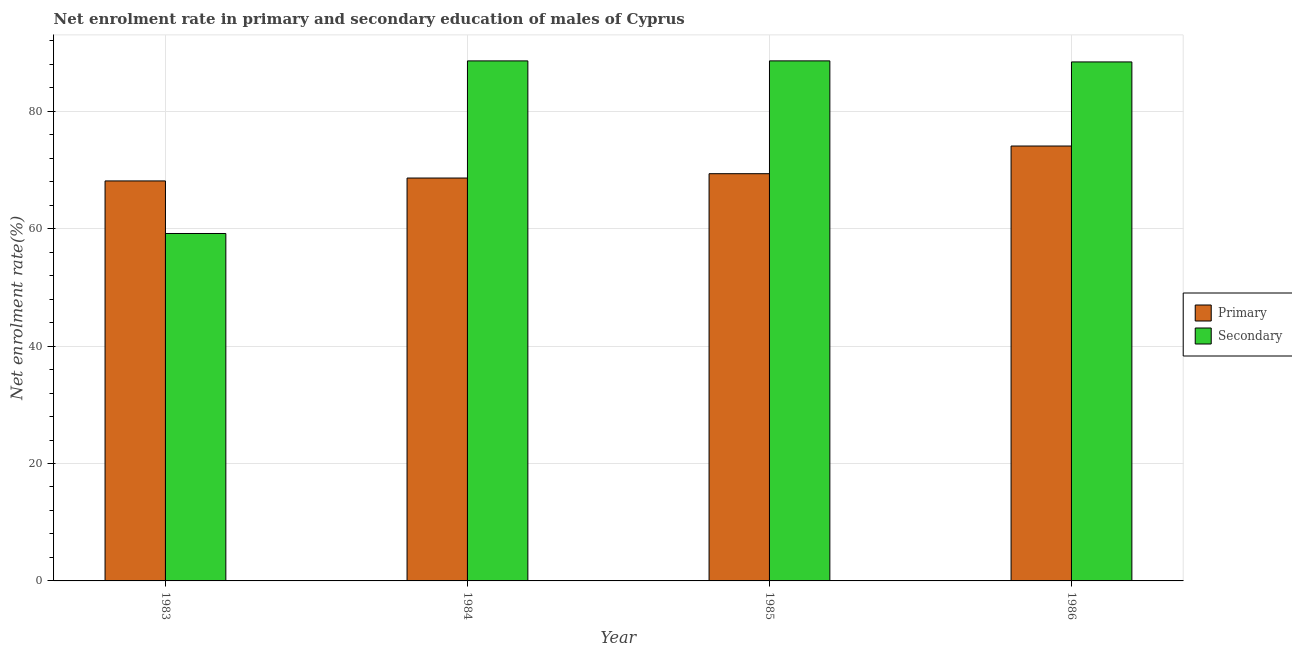How many groups of bars are there?
Provide a succinct answer. 4. Are the number of bars on each tick of the X-axis equal?
Keep it short and to the point. Yes. How many bars are there on the 1st tick from the right?
Your answer should be very brief. 2. What is the label of the 3rd group of bars from the left?
Provide a succinct answer. 1985. In how many cases, is the number of bars for a given year not equal to the number of legend labels?
Offer a very short reply. 0. What is the enrollment rate in primary education in 1984?
Your response must be concise. 68.63. Across all years, what is the maximum enrollment rate in primary education?
Keep it short and to the point. 74.08. Across all years, what is the minimum enrollment rate in secondary education?
Give a very brief answer. 59.19. In which year was the enrollment rate in primary education maximum?
Your response must be concise. 1986. What is the total enrollment rate in secondary education in the graph?
Your response must be concise. 324.77. What is the difference between the enrollment rate in primary education in 1985 and that in 1986?
Your response must be concise. -4.71. What is the difference between the enrollment rate in secondary education in 1984 and the enrollment rate in primary education in 1985?
Provide a succinct answer. -0. What is the average enrollment rate in secondary education per year?
Keep it short and to the point. 81.19. In the year 1986, what is the difference between the enrollment rate in secondary education and enrollment rate in primary education?
Your response must be concise. 0. What is the ratio of the enrollment rate in primary education in 1984 to that in 1986?
Provide a short and direct response. 0.93. What is the difference between the highest and the second highest enrollment rate in primary education?
Your answer should be compact. 4.71. What is the difference between the highest and the lowest enrollment rate in primary education?
Give a very brief answer. 5.95. In how many years, is the enrollment rate in primary education greater than the average enrollment rate in primary education taken over all years?
Ensure brevity in your answer.  1. Is the sum of the enrollment rate in primary education in 1985 and 1986 greater than the maximum enrollment rate in secondary education across all years?
Provide a succinct answer. Yes. What does the 2nd bar from the left in 1985 represents?
Ensure brevity in your answer.  Secondary. What does the 2nd bar from the right in 1986 represents?
Offer a terse response. Primary. Does the graph contain grids?
Your answer should be very brief. Yes. Where does the legend appear in the graph?
Ensure brevity in your answer.  Center right. How are the legend labels stacked?
Give a very brief answer. Vertical. What is the title of the graph?
Offer a terse response. Net enrolment rate in primary and secondary education of males of Cyprus. Does "Boys" appear as one of the legend labels in the graph?
Offer a terse response. No. What is the label or title of the X-axis?
Your response must be concise. Year. What is the label or title of the Y-axis?
Keep it short and to the point. Net enrolment rate(%). What is the Net enrolment rate(%) of Primary in 1983?
Your answer should be compact. 68.14. What is the Net enrolment rate(%) of Secondary in 1983?
Your response must be concise. 59.19. What is the Net enrolment rate(%) in Primary in 1984?
Keep it short and to the point. 68.63. What is the Net enrolment rate(%) of Secondary in 1984?
Keep it short and to the point. 88.59. What is the Net enrolment rate(%) of Primary in 1985?
Offer a very short reply. 69.37. What is the Net enrolment rate(%) in Secondary in 1985?
Your answer should be very brief. 88.59. What is the Net enrolment rate(%) of Primary in 1986?
Provide a succinct answer. 74.08. What is the Net enrolment rate(%) in Secondary in 1986?
Ensure brevity in your answer.  88.41. Across all years, what is the maximum Net enrolment rate(%) of Primary?
Ensure brevity in your answer.  74.08. Across all years, what is the maximum Net enrolment rate(%) of Secondary?
Offer a very short reply. 88.59. Across all years, what is the minimum Net enrolment rate(%) in Primary?
Your response must be concise. 68.14. Across all years, what is the minimum Net enrolment rate(%) in Secondary?
Provide a short and direct response. 59.19. What is the total Net enrolment rate(%) of Primary in the graph?
Make the answer very short. 280.23. What is the total Net enrolment rate(%) in Secondary in the graph?
Offer a terse response. 324.77. What is the difference between the Net enrolment rate(%) in Primary in 1983 and that in 1984?
Ensure brevity in your answer.  -0.49. What is the difference between the Net enrolment rate(%) in Secondary in 1983 and that in 1984?
Offer a very short reply. -29.4. What is the difference between the Net enrolment rate(%) in Primary in 1983 and that in 1985?
Give a very brief answer. -1.23. What is the difference between the Net enrolment rate(%) of Secondary in 1983 and that in 1985?
Your response must be concise. -29.41. What is the difference between the Net enrolment rate(%) of Primary in 1983 and that in 1986?
Make the answer very short. -5.95. What is the difference between the Net enrolment rate(%) of Secondary in 1983 and that in 1986?
Give a very brief answer. -29.23. What is the difference between the Net enrolment rate(%) in Primary in 1984 and that in 1985?
Offer a terse response. -0.74. What is the difference between the Net enrolment rate(%) in Secondary in 1984 and that in 1985?
Provide a succinct answer. -0. What is the difference between the Net enrolment rate(%) of Primary in 1984 and that in 1986?
Give a very brief answer. -5.45. What is the difference between the Net enrolment rate(%) in Secondary in 1984 and that in 1986?
Ensure brevity in your answer.  0.17. What is the difference between the Net enrolment rate(%) in Primary in 1985 and that in 1986?
Provide a succinct answer. -4.71. What is the difference between the Net enrolment rate(%) in Secondary in 1985 and that in 1986?
Provide a succinct answer. 0.18. What is the difference between the Net enrolment rate(%) in Primary in 1983 and the Net enrolment rate(%) in Secondary in 1984?
Keep it short and to the point. -20.45. What is the difference between the Net enrolment rate(%) in Primary in 1983 and the Net enrolment rate(%) in Secondary in 1985?
Offer a terse response. -20.45. What is the difference between the Net enrolment rate(%) of Primary in 1983 and the Net enrolment rate(%) of Secondary in 1986?
Keep it short and to the point. -20.27. What is the difference between the Net enrolment rate(%) in Primary in 1984 and the Net enrolment rate(%) in Secondary in 1985?
Your response must be concise. -19.96. What is the difference between the Net enrolment rate(%) in Primary in 1984 and the Net enrolment rate(%) in Secondary in 1986?
Give a very brief answer. -19.78. What is the difference between the Net enrolment rate(%) of Primary in 1985 and the Net enrolment rate(%) of Secondary in 1986?
Provide a succinct answer. -19.04. What is the average Net enrolment rate(%) in Primary per year?
Your response must be concise. 70.06. What is the average Net enrolment rate(%) of Secondary per year?
Provide a short and direct response. 81.19. In the year 1983, what is the difference between the Net enrolment rate(%) in Primary and Net enrolment rate(%) in Secondary?
Your response must be concise. 8.95. In the year 1984, what is the difference between the Net enrolment rate(%) in Primary and Net enrolment rate(%) in Secondary?
Provide a short and direct response. -19.95. In the year 1985, what is the difference between the Net enrolment rate(%) of Primary and Net enrolment rate(%) of Secondary?
Ensure brevity in your answer.  -19.22. In the year 1986, what is the difference between the Net enrolment rate(%) of Primary and Net enrolment rate(%) of Secondary?
Offer a terse response. -14.33. What is the ratio of the Net enrolment rate(%) in Secondary in 1983 to that in 1984?
Keep it short and to the point. 0.67. What is the ratio of the Net enrolment rate(%) of Primary in 1983 to that in 1985?
Provide a short and direct response. 0.98. What is the ratio of the Net enrolment rate(%) of Secondary in 1983 to that in 1985?
Keep it short and to the point. 0.67. What is the ratio of the Net enrolment rate(%) of Primary in 1983 to that in 1986?
Keep it short and to the point. 0.92. What is the ratio of the Net enrolment rate(%) of Secondary in 1983 to that in 1986?
Give a very brief answer. 0.67. What is the ratio of the Net enrolment rate(%) of Primary in 1984 to that in 1986?
Ensure brevity in your answer.  0.93. What is the ratio of the Net enrolment rate(%) in Primary in 1985 to that in 1986?
Provide a short and direct response. 0.94. What is the difference between the highest and the second highest Net enrolment rate(%) of Primary?
Your answer should be very brief. 4.71. What is the difference between the highest and the second highest Net enrolment rate(%) in Secondary?
Your answer should be compact. 0. What is the difference between the highest and the lowest Net enrolment rate(%) in Primary?
Your response must be concise. 5.95. What is the difference between the highest and the lowest Net enrolment rate(%) in Secondary?
Provide a succinct answer. 29.41. 